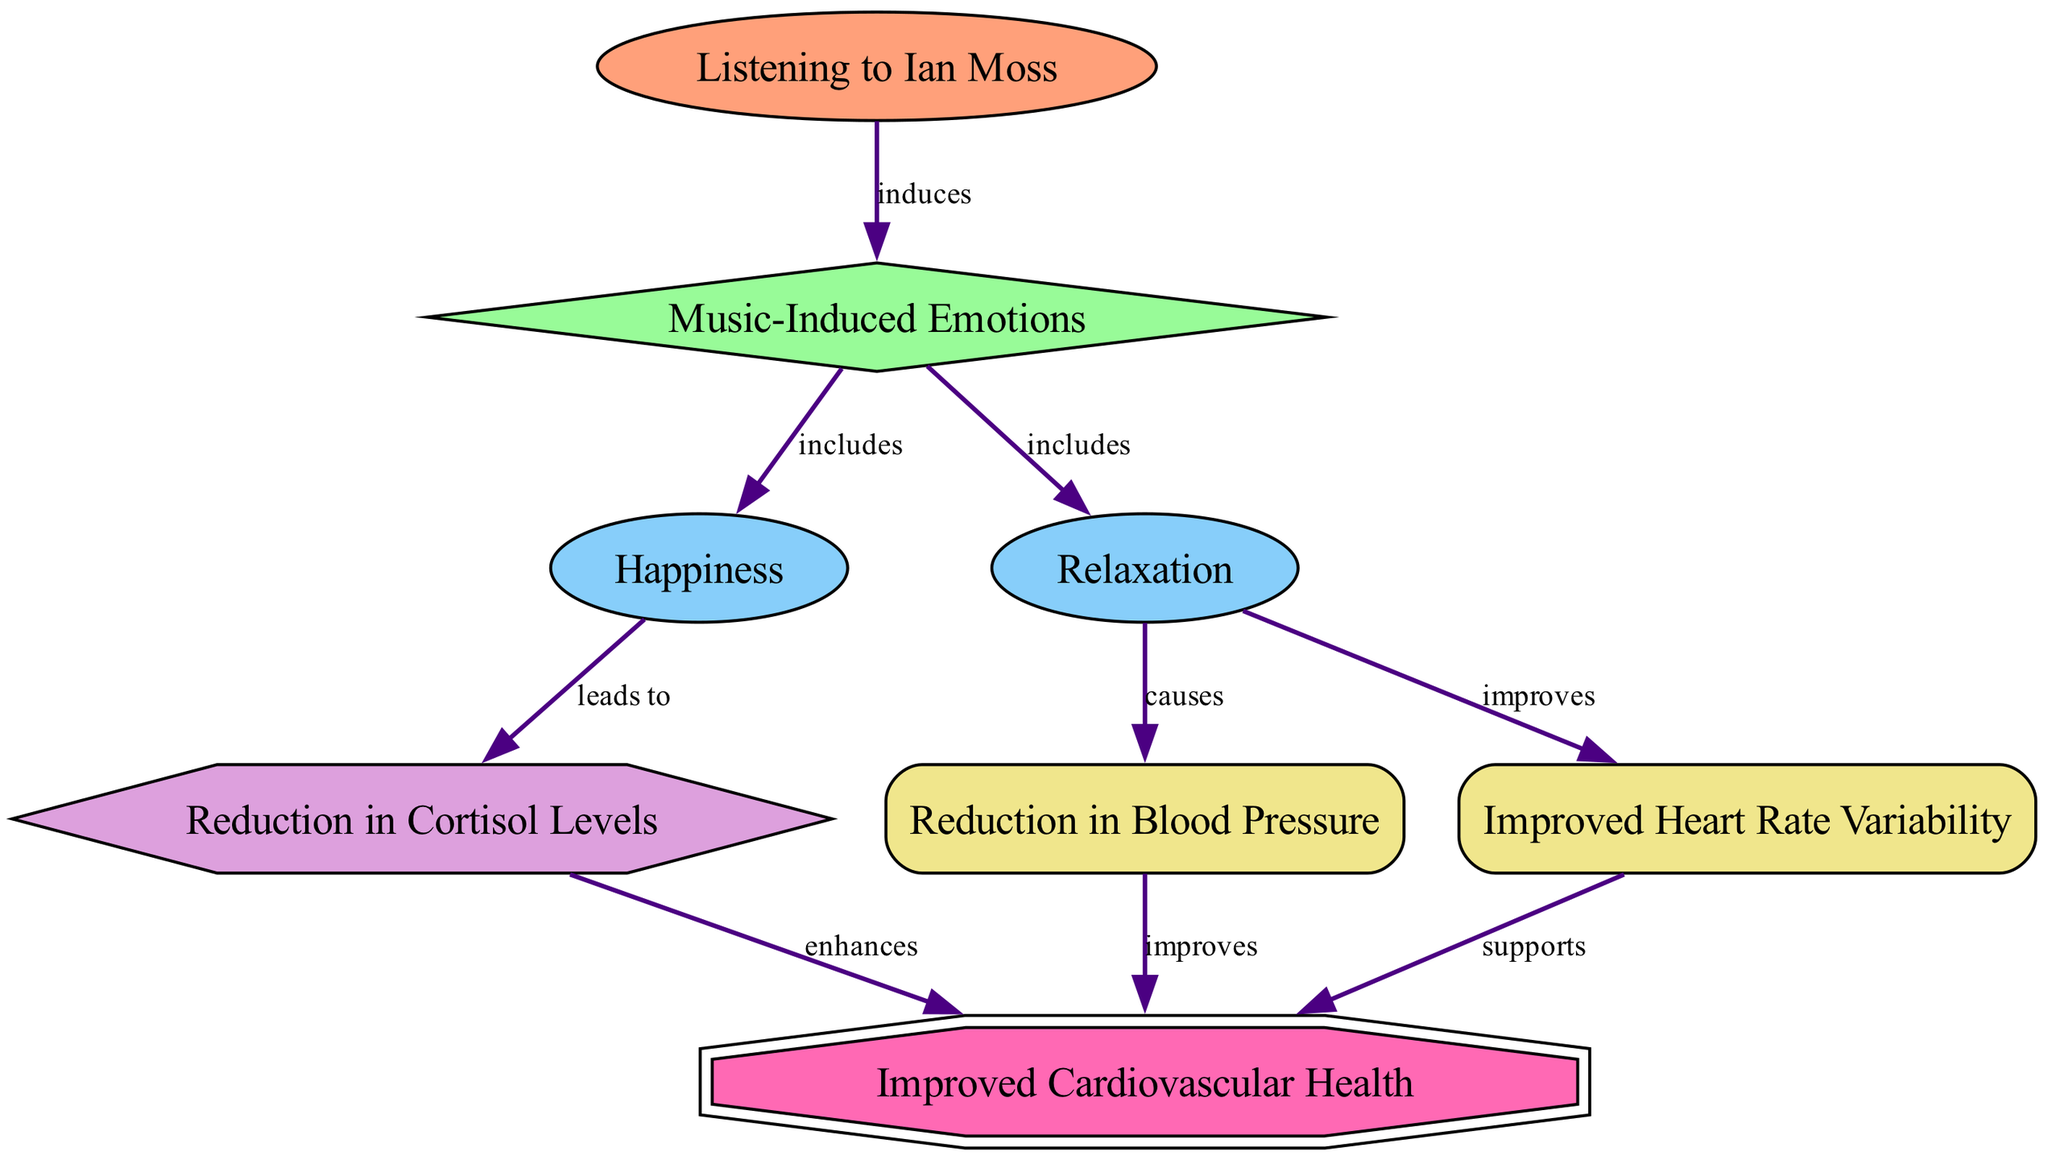What is the initial activity in this diagram? The starting point of the diagram is the node labeled "Listening to Ian Moss," which is identified as the initial activity that induces emotions.
Answer: Listening to Ian Moss How many emotions are included in the diagram? The diagram shows two emotions that are included under "Music-Induced Emotions": "Happiness" and "Relaxation." Therefore, there are two emotions.
Answer: 2 What physiological effect does "Relaxation" cause? According to the diagram, "Relaxation" causes a reduction in blood pressure, which is categorized under physiological effects.
Answer: Reduction in Blood Pressure Which node is supported by "Improved Heart Rate Variability"? The node labeled "Improved Heart Rate Variability" supports the node "Improved Cardiovascular Health," indicating its contribution to that health outcome.
Answer: Improved Cardiovascular Health What is the relationship between "Happiness" and "CortisolReduction"? The diagram indicates that "Happiness" leads to "Reduction in Cortisol Levels," showing a direct causative relationship between the two nodes.
Answer: leads to What biochemical effect accompanies the state of "Happiness"? The diagram specifies that "Happiness" leads to a reduction in cortisol levels, which is a biochemical effect associated with experiencing happiness.
Answer: Reduction in Cortisol Levels How does "Relaxation" improve cardiovascular health? "Relaxation" improves cardiovascular health by causing a reduction in blood pressure and improving heart rate variability, both of which directly contribute to better cardiovascular health outcomes.
Answer: Reduction in Blood Pressure and Improved Heart Rate Variability Which emotions are classified under "Music-Induced Emotions"? The emotions classified under "Music-Induced Emotions" include "Happiness" and "Relaxation," representing the emotional states experienced from listening to music.
Answer: Happiness and Relaxation What effect does "CortisolReduction" have on cardiovascular health? The diagram indicates that "Reduction in Cortisol Levels" enhances "Improved Cardiovascular Health," suggesting a positive impact of cortisol reduction on heart health.
Answer: enhances 